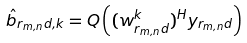<formula> <loc_0><loc_0><loc_500><loc_500>\hat { b } _ { r _ { m , n } d , k } = Q \left ( ( w ^ { k } _ { r _ { m , n } d } ) ^ { H } y _ { r _ { m , n } d } \right )</formula> 